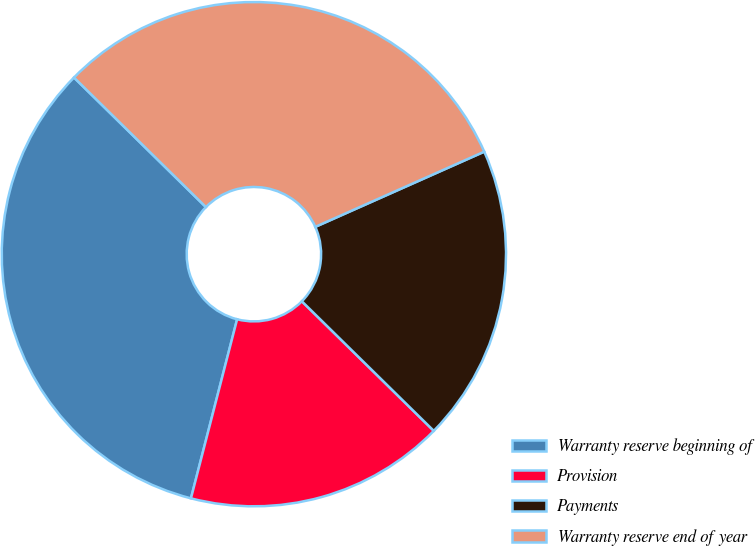Convert chart. <chart><loc_0><loc_0><loc_500><loc_500><pie_chart><fcel>Warranty reserve beginning of<fcel>Provision<fcel>Payments<fcel>Warranty reserve end of year<nl><fcel>33.34%<fcel>16.66%<fcel>19.02%<fcel>30.98%<nl></chart> 